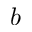Convert formula to latex. <formula><loc_0><loc_0><loc_500><loc_500>b</formula> 